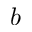Convert formula to latex. <formula><loc_0><loc_0><loc_500><loc_500>b</formula> 